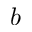Convert formula to latex. <formula><loc_0><loc_0><loc_500><loc_500>b</formula> 